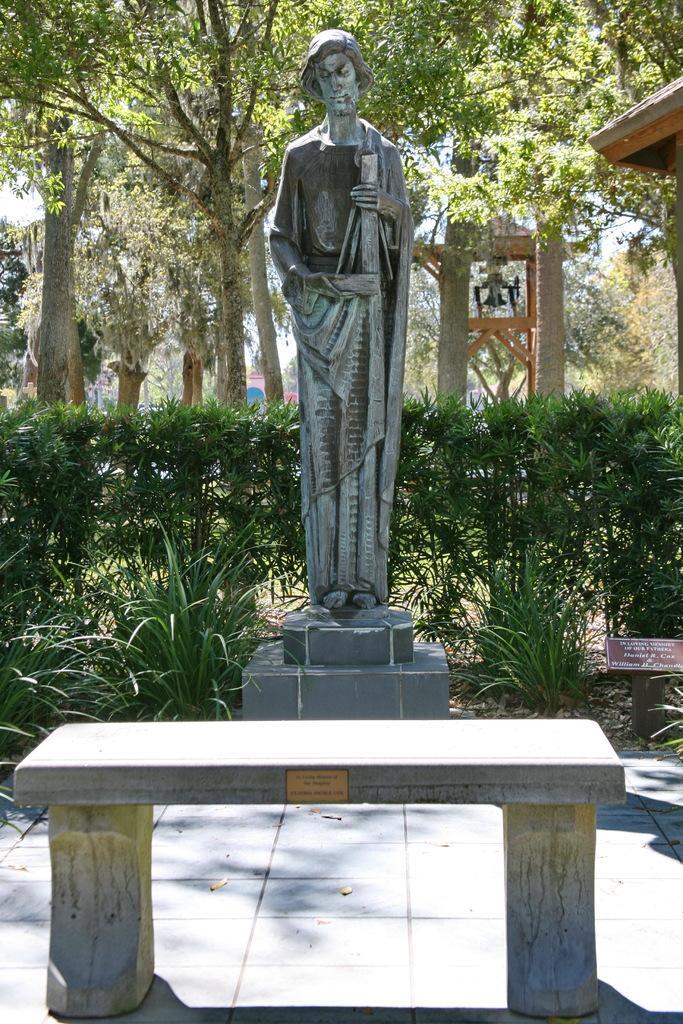Could you give a brief overview of what you see in this image? In this picture there is a statue in front of a small tree and also a chair. 